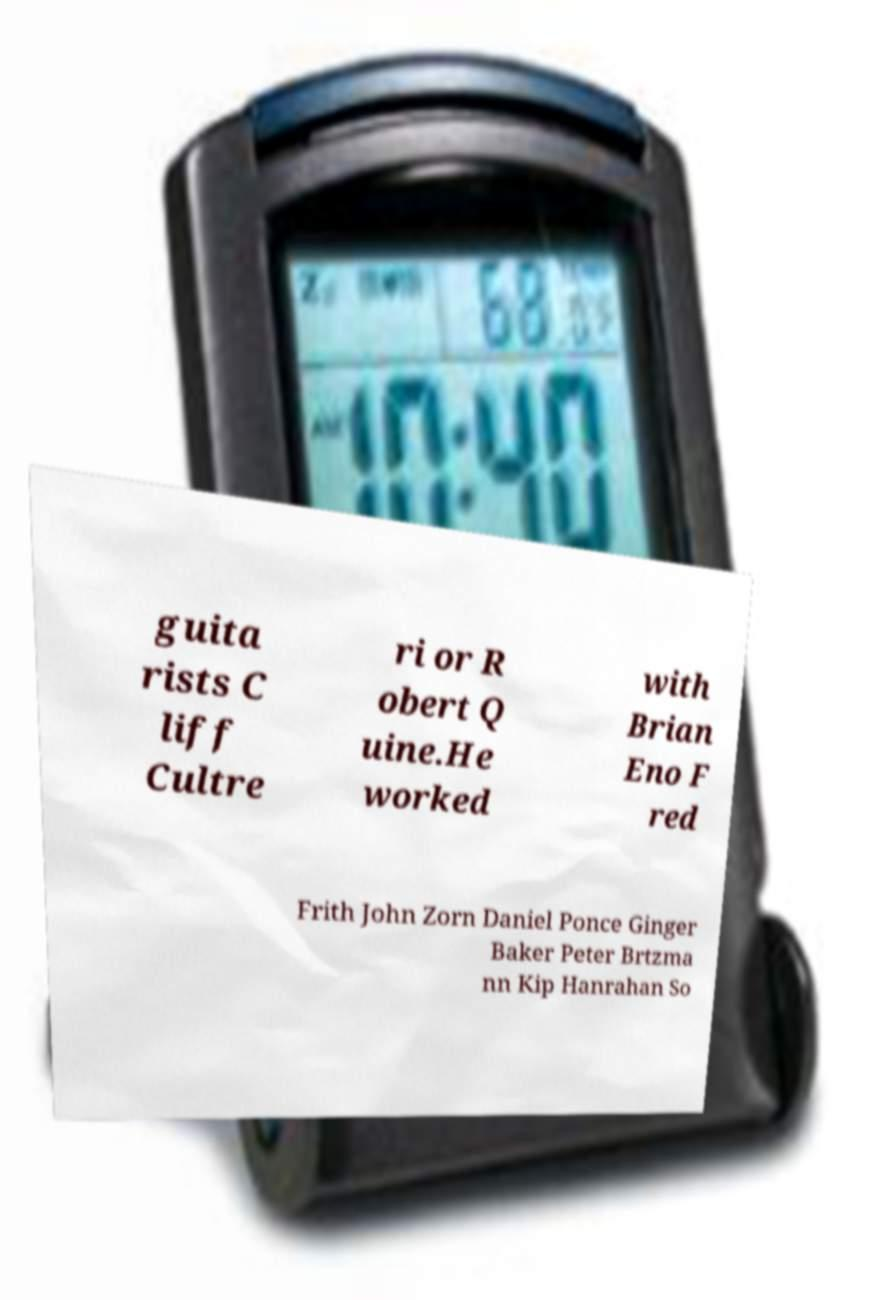What messages or text are displayed in this image? I need them in a readable, typed format. guita rists C liff Cultre ri or R obert Q uine.He worked with Brian Eno F red Frith John Zorn Daniel Ponce Ginger Baker Peter Brtzma nn Kip Hanrahan So 